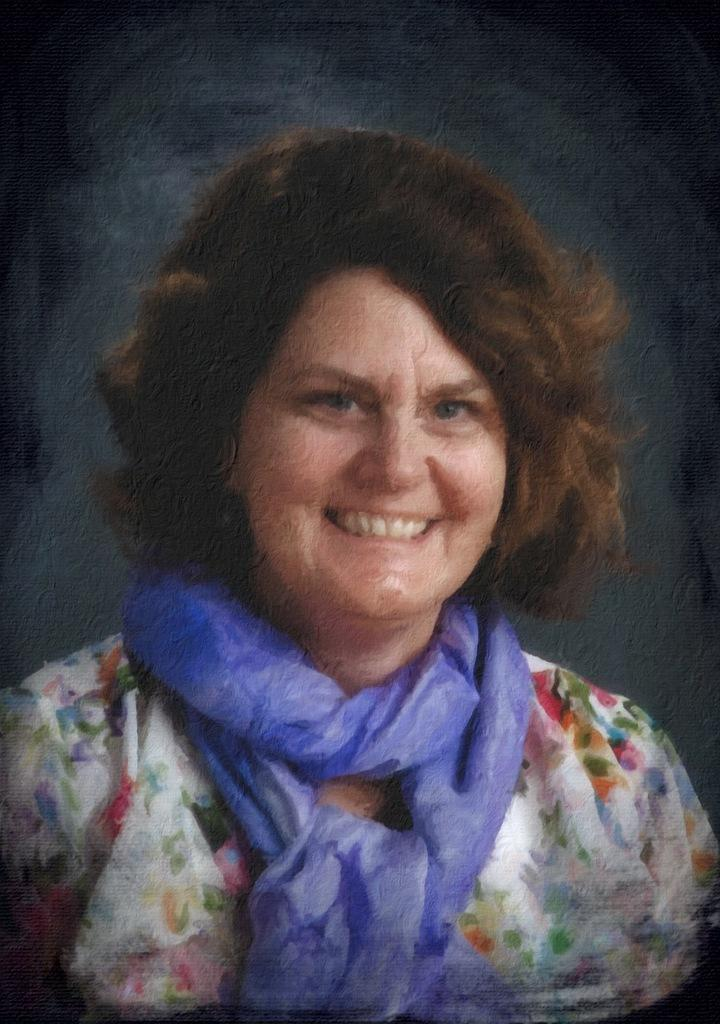What type of artwork is the image? The image is a painting. What subject is depicted in the painting? The painting depicts a woman. Can you tell me where the woman's badge is located in the painting? There is no mention of a badge in the painting, so it cannot be determined where it might be located. Who is the owner of the painting? The information provided does not include any details about the owner of the painting. 